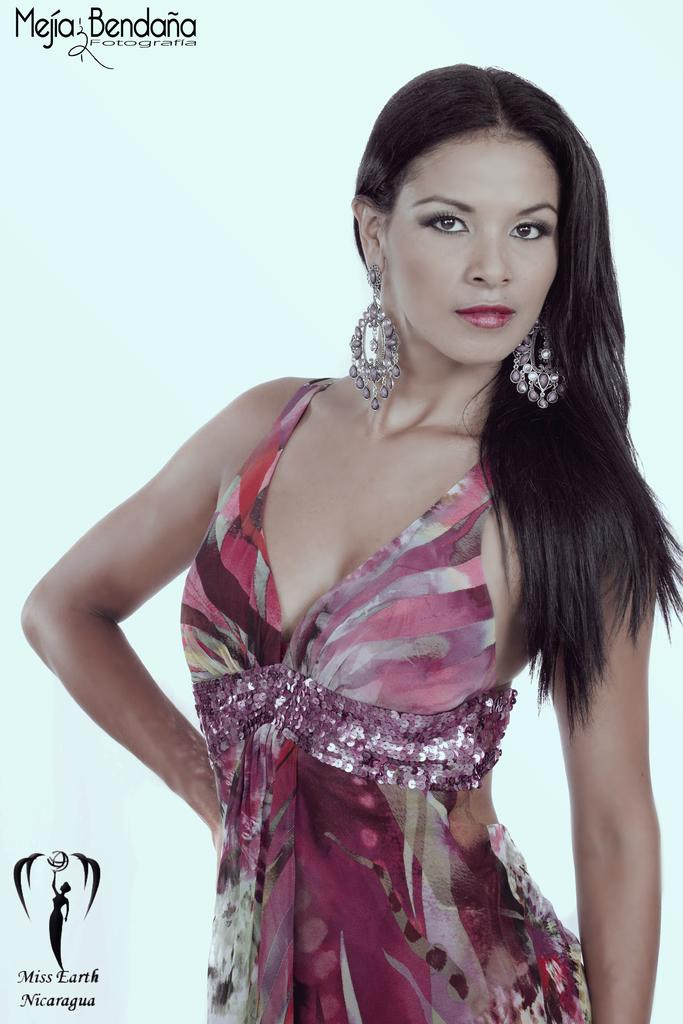Who is the main subject in the image? There is a woman in the image. What can be seen at the bottom left of the image? There is text at the bottom left of the image. What can be seen at the top left of the image? There is text at the top left of the image. What color is the background of the image? The background of the image is white. What page is the actor turning in the image? There is no actor or page present in the image; it features a woman and text on a white background. 